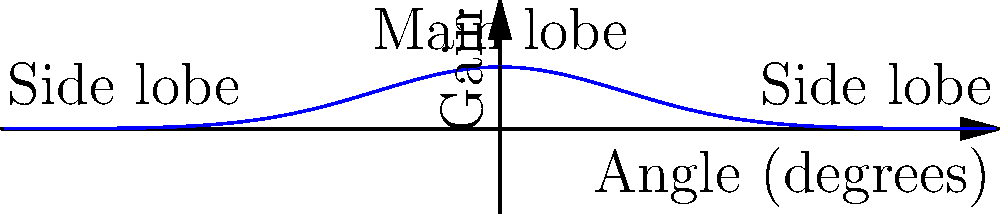The diagram shows the gain pattern of a radio telescope's dish. At what angle should the telescope be pointed to receive the strongest signal from a celestial source? To determine the optimal pointing direction for the radio telescope, we need to analyze the gain pattern shown in the diagram. Here's a step-by-step explanation:

1. The gain pattern represents the sensitivity of the radio telescope at different angles.

2. The vertical axis represents the gain (sensitivity) of the telescope, while the horizontal axis represents the angle of observation.

3. The central peak in the diagram is called the main lobe. This is where the telescope is most sensitive to incoming signals.

4. The smaller peaks on either side of the main lobe are called side lobes. These represent areas of lower sensitivity.

5. To receive the strongest signal, we want to point the telescope in the direction of maximum gain.

6. The maximum gain occurs at the peak of the main lobe, which is located at the center of the diagram.

7. The center of the diagram corresponds to an angle of 0 degrees on the horizontal axis.

Therefore, the optimal pointing direction for the radio telescope to receive the strongest signal is at an angle of 0 degrees, which aligns with the peak of the main lobe.
Answer: 0 degrees 